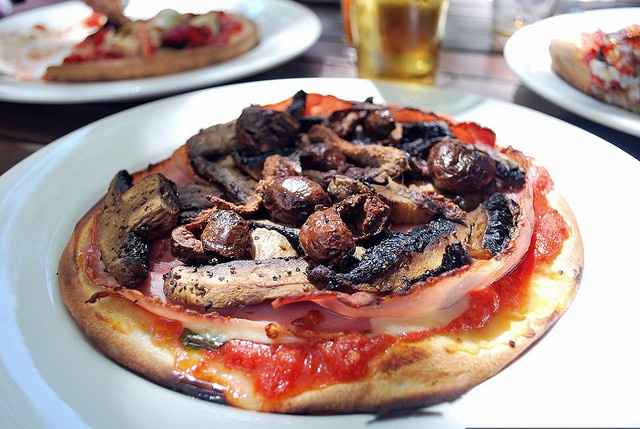Describe the objects in this image and their specific colors. I can see pizza in lavender, black, brown, maroon, and ivory tones, pizza in lavender, brown, maroon, tan, and darkgray tones, cup in lavender, olive, maroon, and tan tones, and pizza in lavender, darkgray, brown, gray, and white tones in this image. 